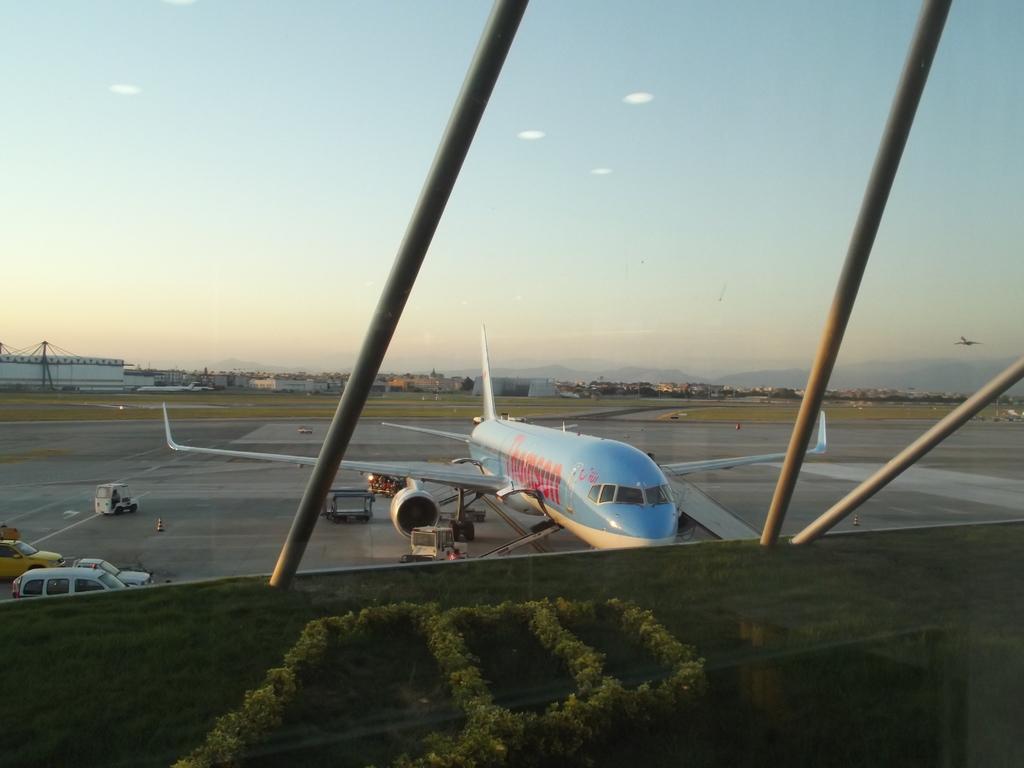Can you describe this image briefly? In this image, I can see an airplane and few vehicles on the runway. In the background, I can see the buildings. At the bottom of the image, there are bushes and grass. I can see a glass door with the iron poles. On the right side of the image, there is an airplane flying in the sky. 